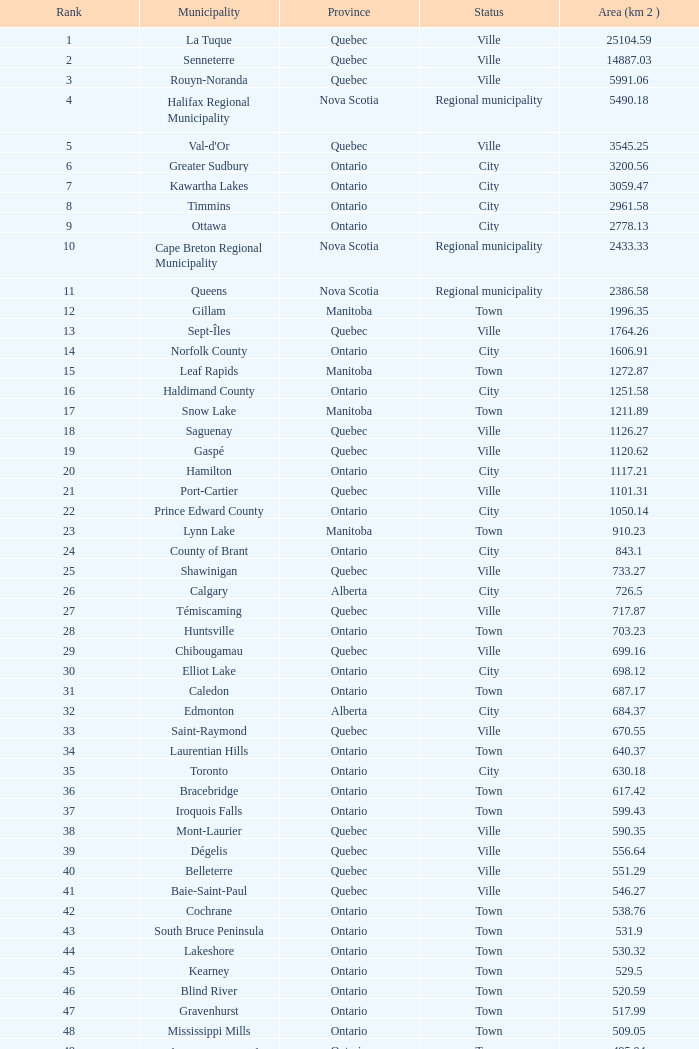Which listed status corresponds to the province of ontario and has an 86 rank? Town. 